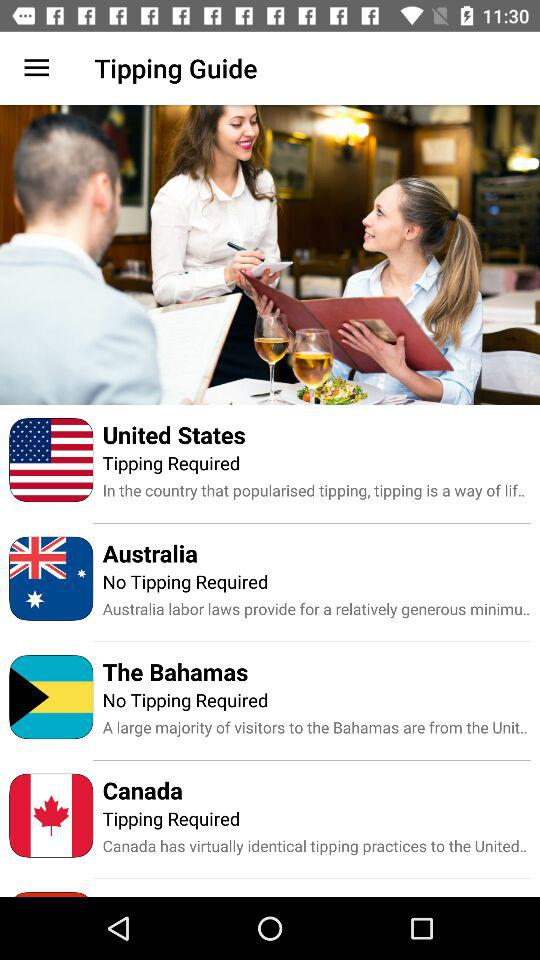How many countries does the tipping guide cover?
Answer the question using a single word or phrase. 4 